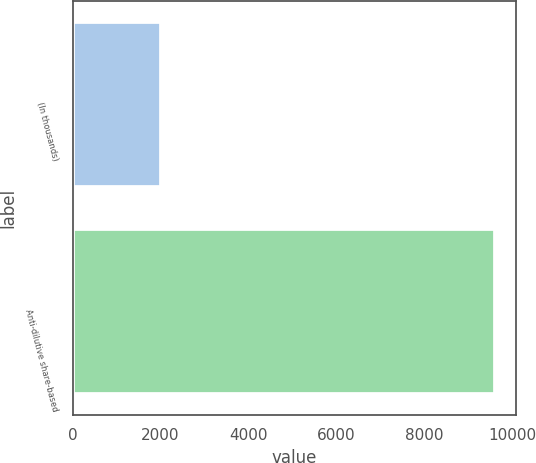<chart> <loc_0><loc_0><loc_500><loc_500><bar_chart><fcel>(In thousands)<fcel>Anti-dilutive share-based<nl><fcel>2009<fcel>9603<nl></chart> 